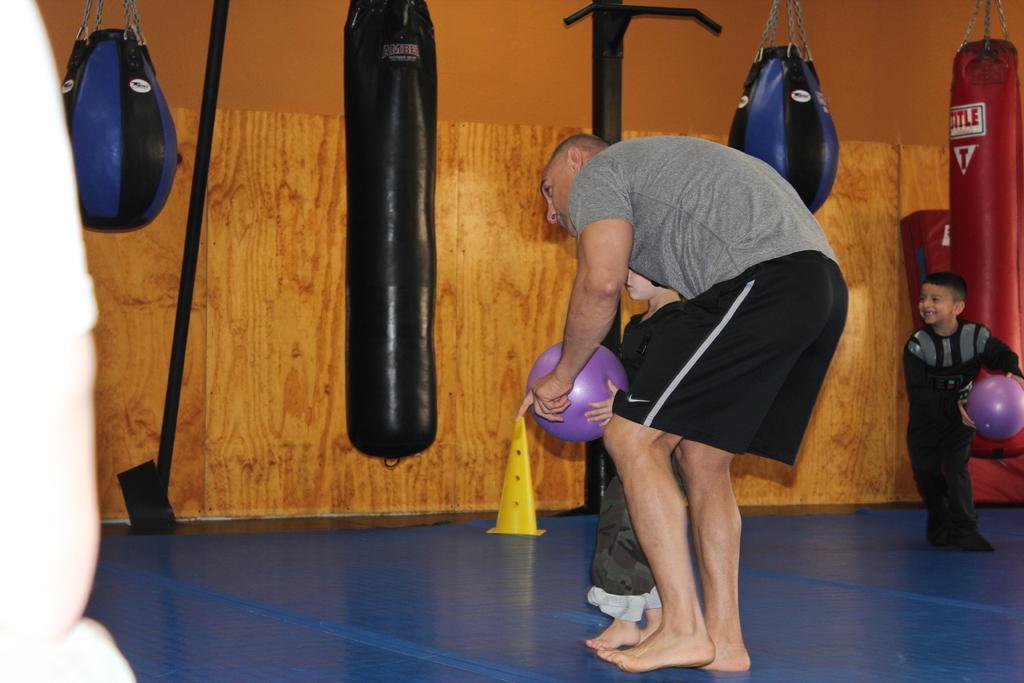In one or two sentences, can you explain what this image depicts? In this picture I can see a man and two boys holding the balls, there are boxing speed balls and punching bags, and some other items. 